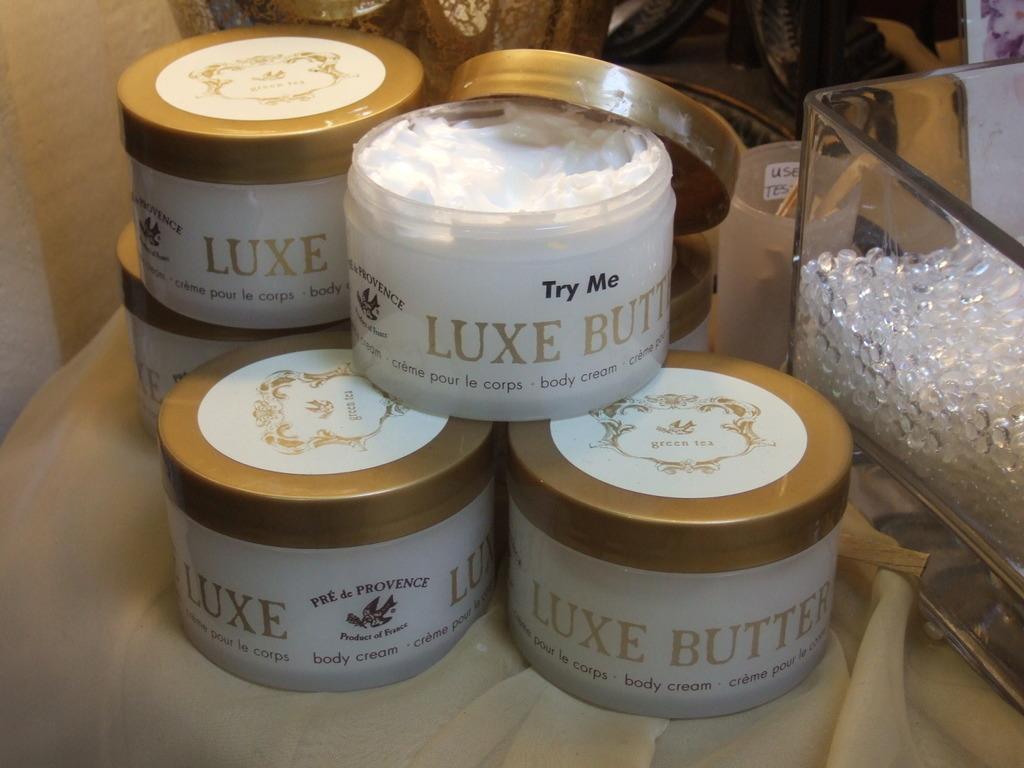Could you give a brief overview of what you see in this image? In this picture I can see the boxes and glass box which are kept on the table. At the top I can see the couch. On the left I can see the light beam on the wall. 